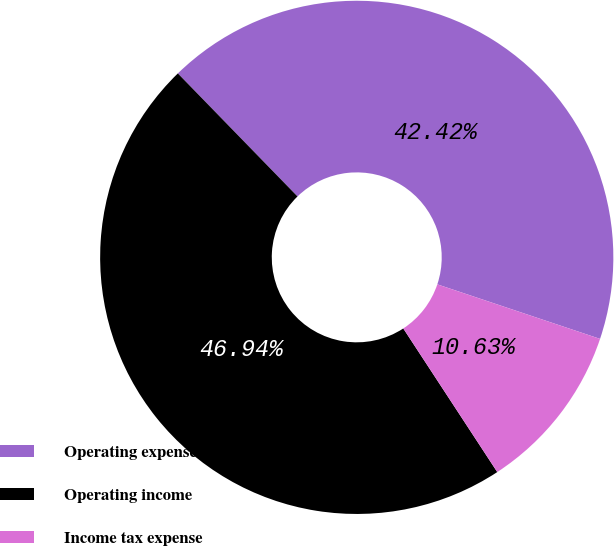Convert chart. <chart><loc_0><loc_0><loc_500><loc_500><pie_chart><fcel>Operating expenses<fcel>Operating income<fcel>Income tax expense<nl><fcel>42.42%<fcel>46.94%<fcel>10.63%<nl></chart> 